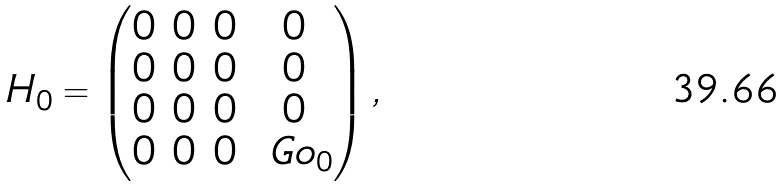Convert formula to latex. <formula><loc_0><loc_0><loc_500><loc_500>H _ { 0 } = \begin{pmatrix} 0 & 0 & 0 & 0 \\ 0 & 0 & 0 & 0 \\ 0 & 0 & 0 & 0 \\ 0 & 0 & 0 & \ G o _ { 0 } \end{pmatrix} ,</formula> 